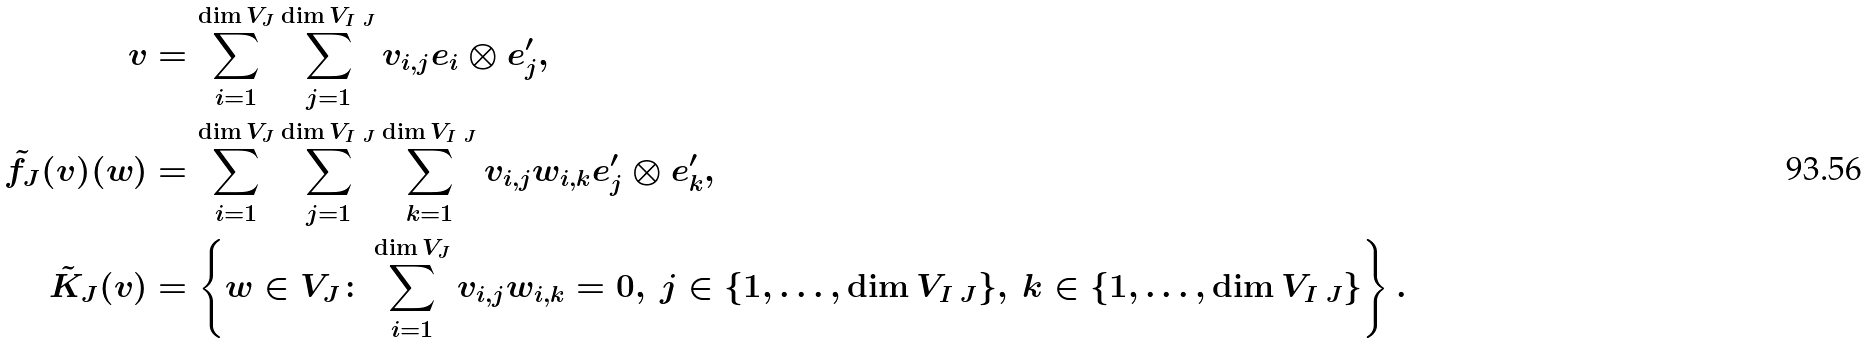<formula> <loc_0><loc_0><loc_500><loc_500>v & = \sum _ { i = 1 } ^ { \dim { V _ { J } } } \sum _ { j = 1 } ^ { \dim { V _ { I \ J } } } v _ { i , j } e _ { i } \otimes e ^ { \prime } _ { j } , \\ \tilde { f } _ { J } ( v ) ( w ) & = \sum _ { i = 1 } ^ { \dim { V _ { J } } } \sum _ { j = 1 } ^ { \dim { V _ { I \ J } } } \sum _ { k = 1 } ^ { \dim { V _ { I \ J } } } v _ { i , j } w _ { i , k } e ^ { \prime } _ { j } \otimes e ^ { \prime } _ { k } , \\ \tilde { K } _ { J } ( v ) & = \left \{ w \in V _ { J } \colon \sum _ { i = 1 } ^ { \dim { V _ { J } } } v _ { i , j } w _ { i , k } = 0 , \ j \in \{ 1 , \dots , \dim { V _ { I \ J } } \} , \ k \in \{ 1 , \dots , \dim { V _ { I \ J } } \} \right \} .</formula> 